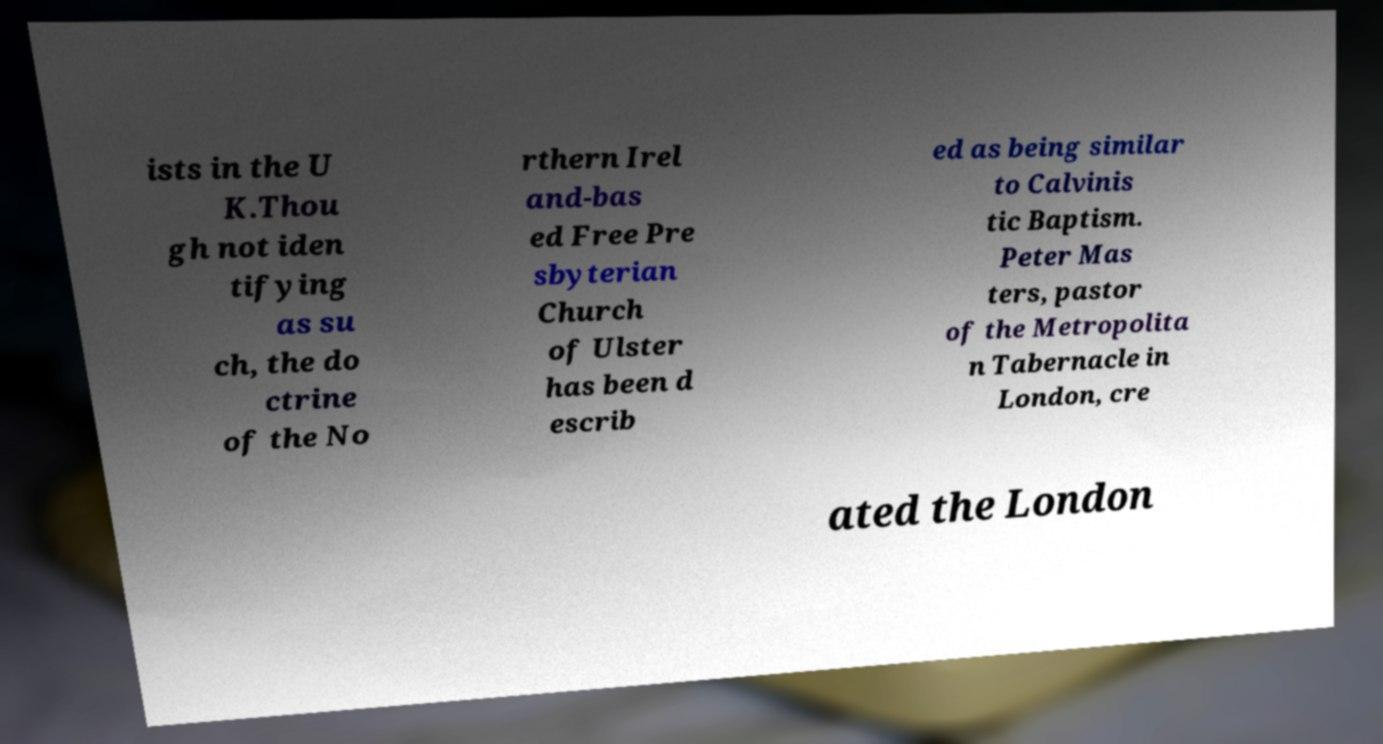Could you assist in decoding the text presented in this image and type it out clearly? ists in the U K.Thou gh not iden tifying as su ch, the do ctrine of the No rthern Irel and-bas ed Free Pre sbyterian Church of Ulster has been d escrib ed as being similar to Calvinis tic Baptism. Peter Mas ters, pastor of the Metropolita n Tabernacle in London, cre ated the London 